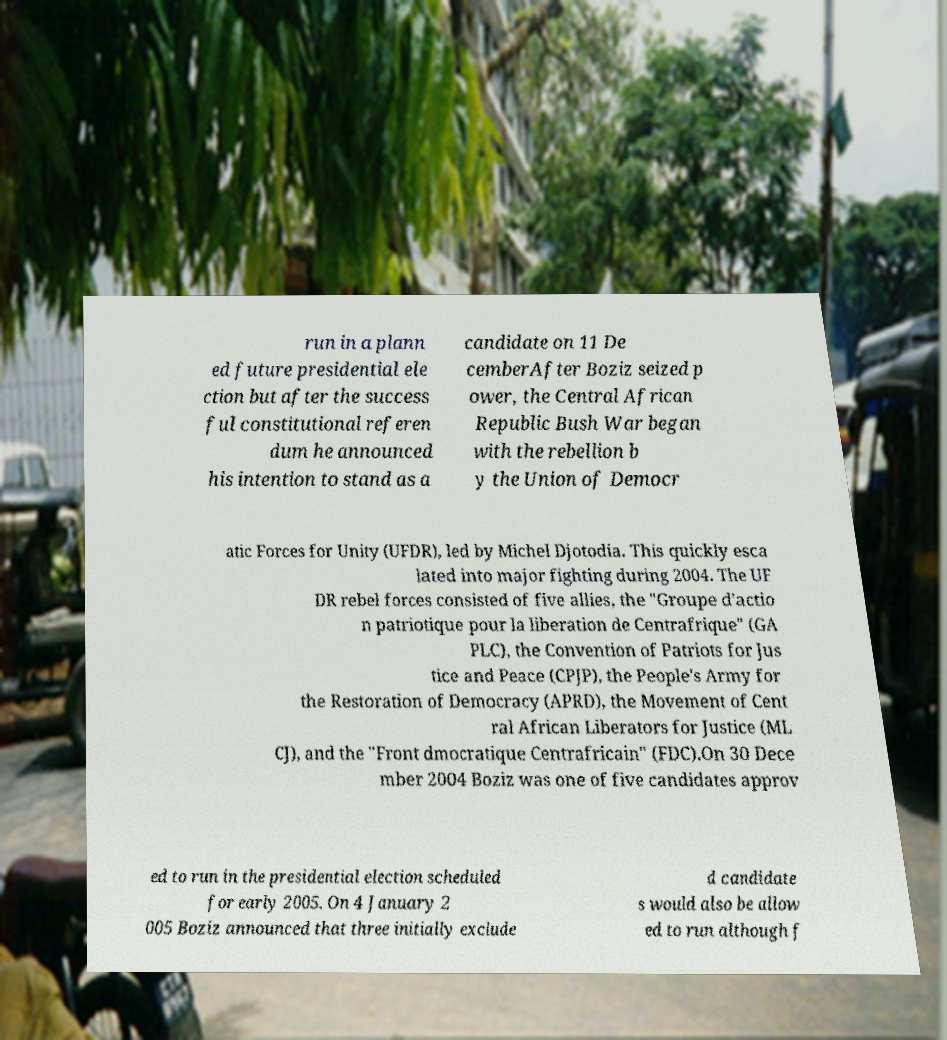Can you accurately transcribe the text from the provided image for me? run in a plann ed future presidential ele ction but after the success ful constitutional referen dum he announced his intention to stand as a candidate on 11 De cemberAfter Boziz seized p ower, the Central African Republic Bush War began with the rebellion b y the Union of Democr atic Forces for Unity (UFDR), led by Michel Djotodia. This quickly esca lated into major fighting during 2004. The UF DR rebel forces consisted of five allies, the "Groupe d'actio n patriotique pour la liberation de Centrafrique" (GA PLC), the Convention of Patriots for Jus tice and Peace (CPJP), the People's Army for the Restoration of Democracy (APRD), the Movement of Cent ral African Liberators for Justice (ML CJ), and the "Front dmocratique Centrafricain" (FDC).On 30 Dece mber 2004 Boziz was one of five candidates approv ed to run in the presidential election scheduled for early 2005. On 4 January 2 005 Boziz announced that three initially exclude d candidate s would also be allow ed to run although f 